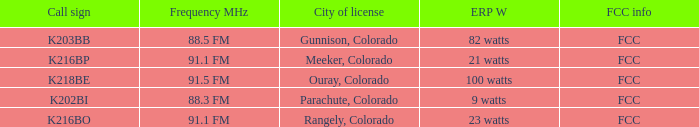Which Frequency MHz has a Call Sign of K218BE? 91.5 FM. 